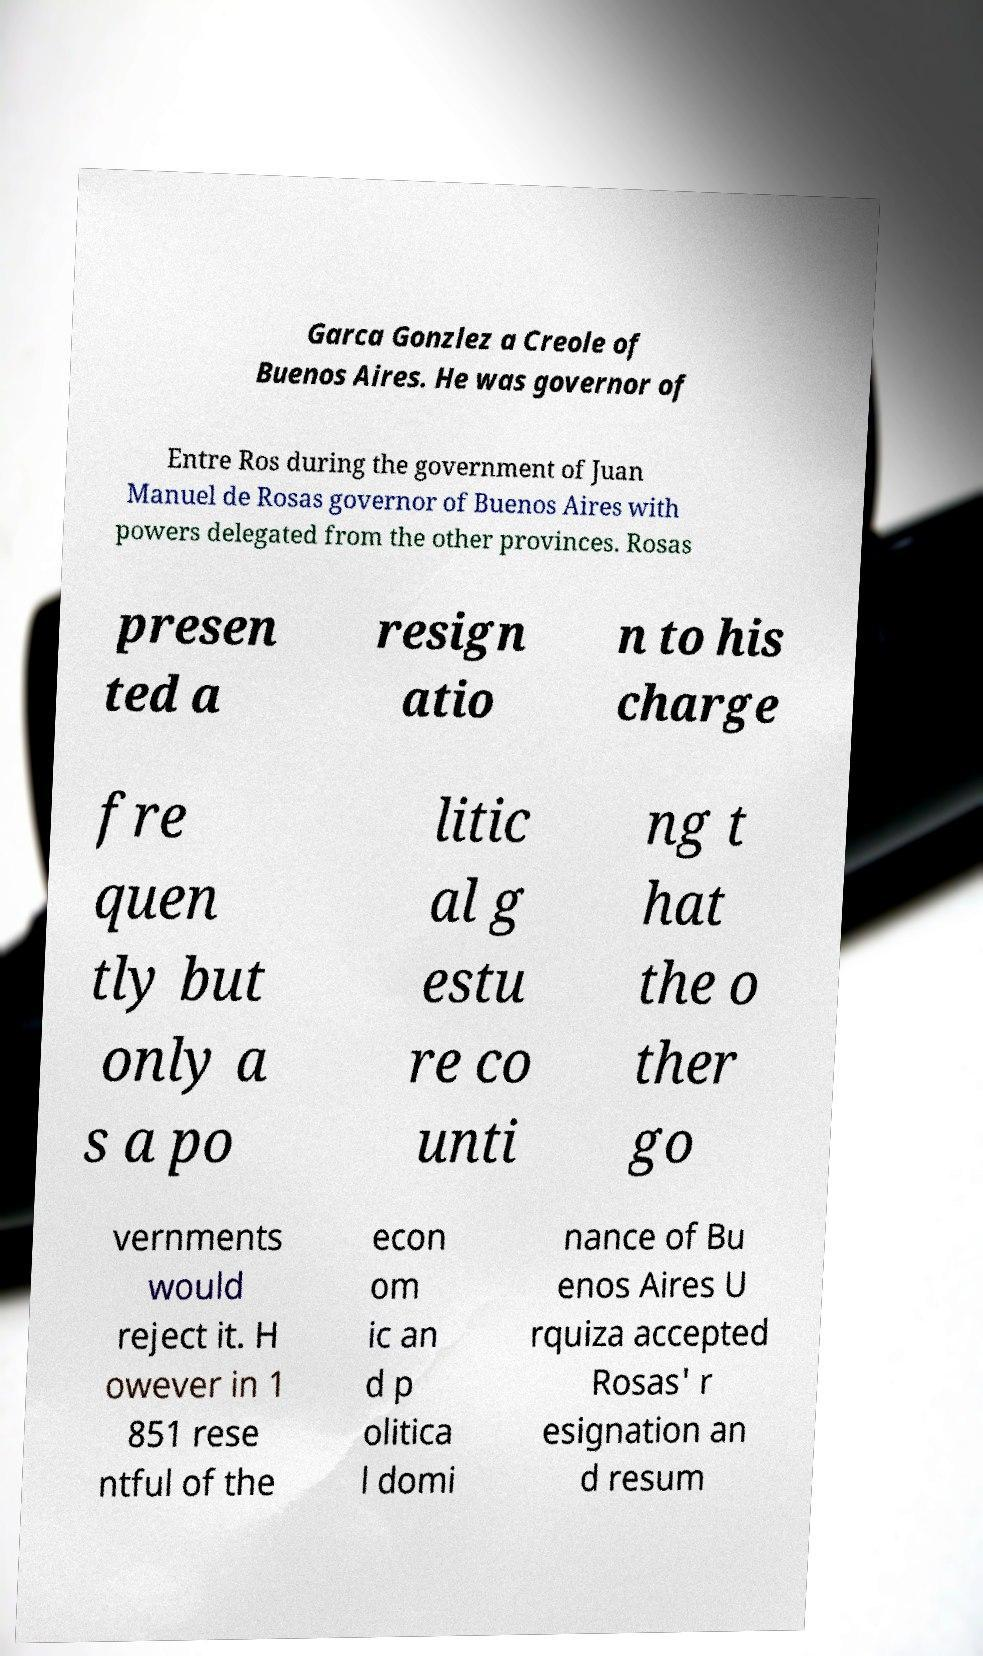What messages or text are displayed in this image? I need them in a readable, typed format. Garca Gonzlez a Creole of Buenos Aires. He was governor of Entre Ros during the government of Juan Manuel de Rosas governor of Buenos Aires with powers delegated from the other provinces. Rosas presen ted a resign atio n to his charge fre quen tly but only a s a po litic al g estu re co unti ng t hat the o ther go vernments would reject it. H owever in 1 851 rese ntful of the econ om ic an d p olitica l domi nance of Bu enos Aires U rquiza accepted Rosas' r esignation an d resum 